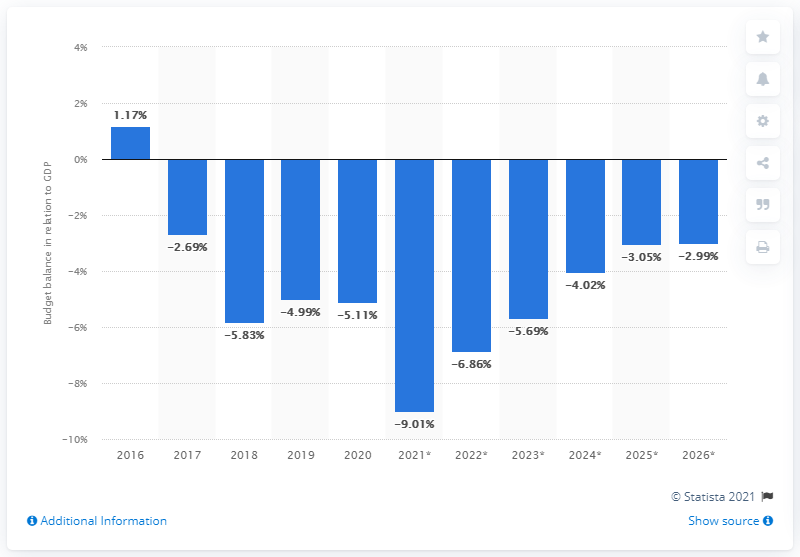Give some essential details in this illustration. The budget balance of Nepal ended in 2020. 